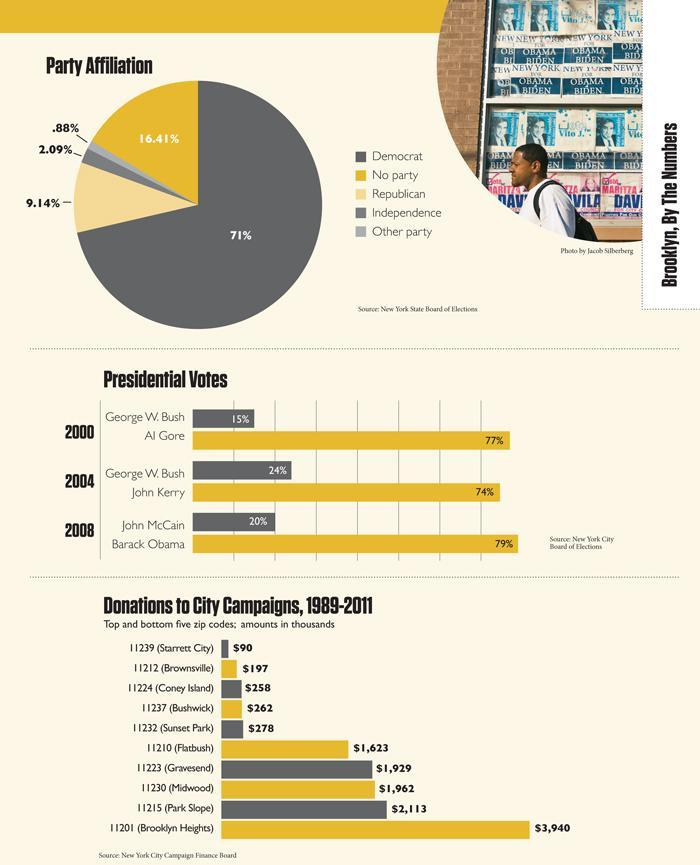what is the presidential vote share of Barack Obama in 2008?
Answer the question with a short phrase. 79% what is the presidential vote share of Al Gore in 2000? 77 what is the presidential vote share of John McCain in 2008? 20 which city got lowest donations for campaign(1989-2011)? Starrett city In pie chart, what is the total percentage of Democrats and republicans affiliation combined? 80.14% what is the presidential vote share of George W Bush in 2004? 24 which city got second highest donations for campaign(1989-2011)? Park slope what is the presidential vote share of John Kerry in 2004? 74 what are the top 3 cities which got highest donations? Brooklyn heights, Park slope, Midwood what is the zip code of Gravesend? 11223 which city got highest donations for campaign(1989-2011)? Brooklyn heights what is the presidential vote share of George W Bush in 2000? 15 